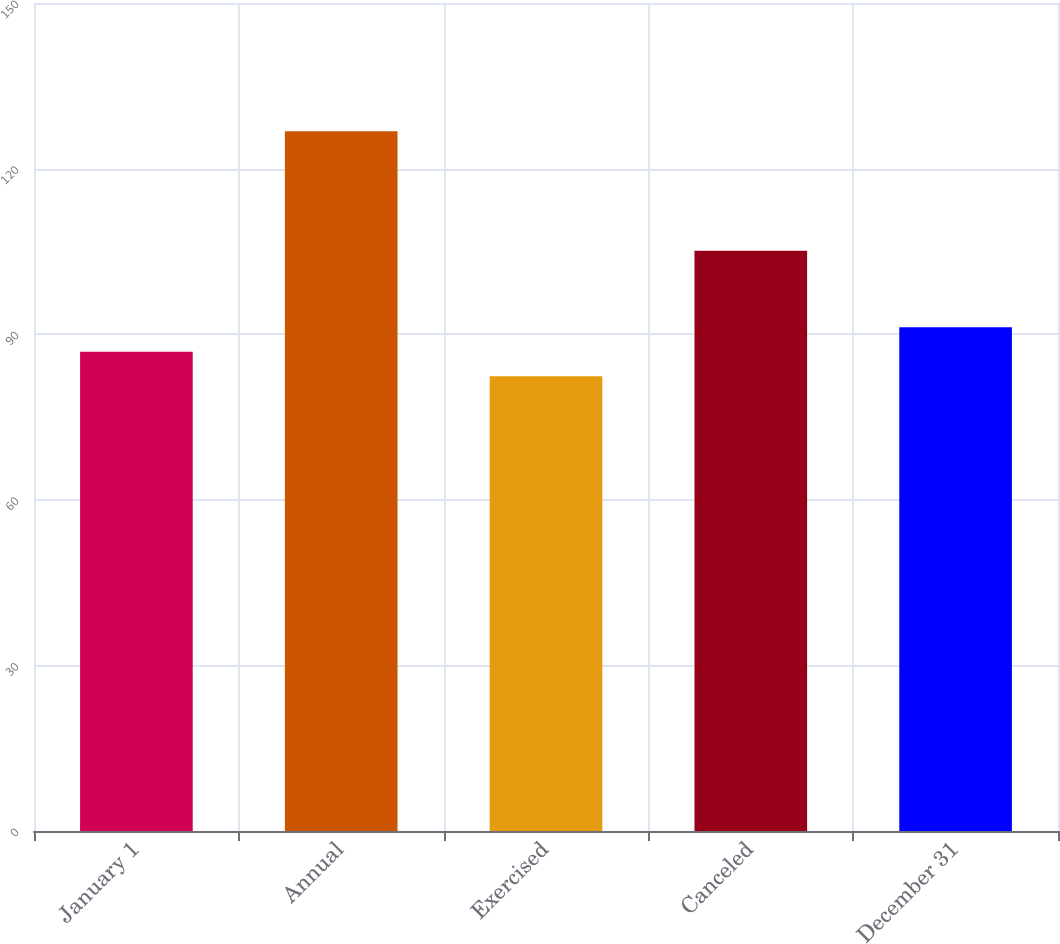Convert chart to OTSL. <chart><loc_0><loc_0><loc_500><loc_500><bar_chart><fcel>January 1<fcel>Annual<fcel>Exercised<fcel>Canceled<fcel>December 31<nl><fcel>86.81<fcel>126.77<fcel>82.37<fcel>105.11<fcel>91.25<nl></chart> 